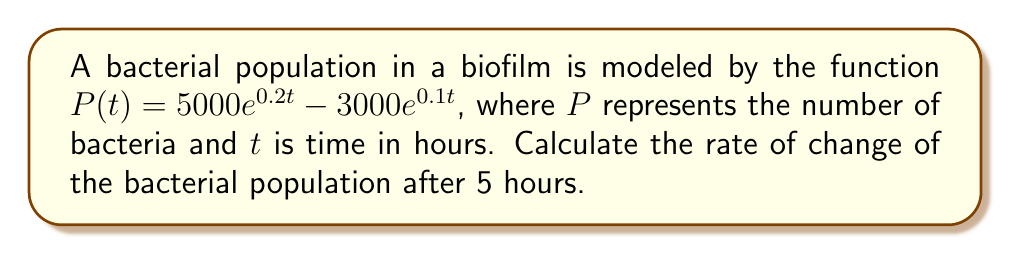What is the answer to this math problem? To solve this problem, we need to follow these steps:

1) The rate of change of the population is given by the derivative of $P(t)$ with respect to $t$.

2) Let's find $\frac{dP}{dt}$ using the derivative rules:

   $$\frac{dP}{dt} = \frac{d}{dt}(5000e^{0.2t} - 3000e^{0.1t})$$

3) Using the chain rule:

   $$\frac{dP}{dt} = 5000 \cdot 0.2e^{0.2t} - 3000 \cdot 0.1e^{0.1t}$$

4) Simplifying:

   $$\frac{dP}{dt} = 1000e^{0.2t} - 300e^{0.1t}$$

5) Now, we need to evaluate this at $t = 5$:

   $$\frac{dP}{dt}\bigg|_{t=5} = 1000e^{0.2(5)} - 300e^{0.1(5)}$$

6) Calculate the exponentials:

   $$\frac{dP}{dt}\bigg|_{t=5} = 1000e^1 - 300e^{0.5}$$

7) Evaluate:

   $$\frac{dP}{dt}\bigg|_{t=5} \approx 1000 \cdot 2.71828 - 300 \cdot 1.64872$$

8) Final calculation:

   $$\frac{dP}{dt}\bigg|_{t=5} \approx 2718.28 - 494.62 \approx 2223.66$$
Answer: $2223.66$ bacteria per hour 